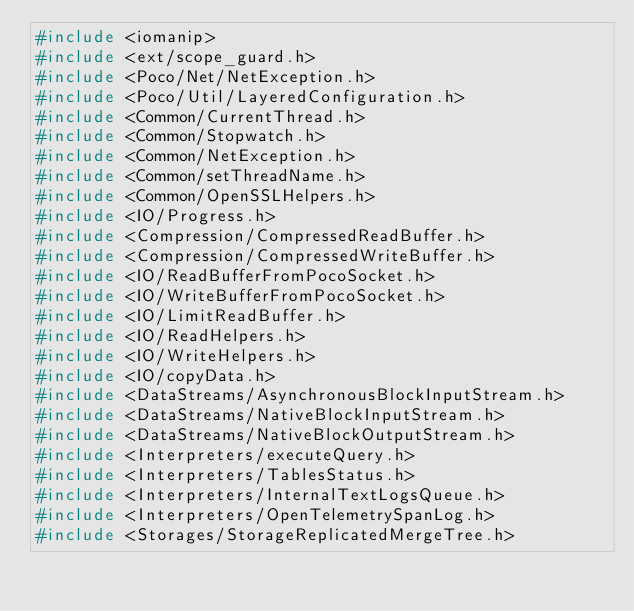Convert code to text. <code><loc_0><loc_0><loc_500><loc_500><_C++_>#include <iomanip>
#include <ext/scope_guard.h>
#include <Poco/Net/NetException.h>
#include <Poco/Util/LayeredConfiguration.h>
#include <Common/CurrentThread.h>
#include <Common/Stopwatch.h>
#include <Common/NetException.h>
#include <Common/setThreadName.h>
#include <Common/OpenSSLHelpers.h>
#include <IO/Progress.h>
#include <Compression/CompressedReadBuffer.h>
#include <Compression/CompressedWriteBuffer.h>
#include <IO/ReadBufferFromPocoSocket.h>
#include <IO/WriteBufferFromPocoSocket.h>
#include <IO/LimitReadBuffer.h>
#include <IO/ReadHelpers.h>
#include <IO/WriteHelpers.h>
#include <IO/copyData.h>
#include <DataStreams/AsynchronousBlockInputStream.h>
#include <DataStreams/NativeBlockInputStream.h>
#include <DataStreams/NativeBlockOutputStream.h>
#include <Interpreters/executeQuery.h>
#include <Interpreters/TablesStatus.h>
#include <Interpreters/InternalTextLogsQueue.h>
#include <Interpreters/OpenTelemetrySpanLog.h>
#include <Storages/StorageReplicatedMergeTree.h></code> 